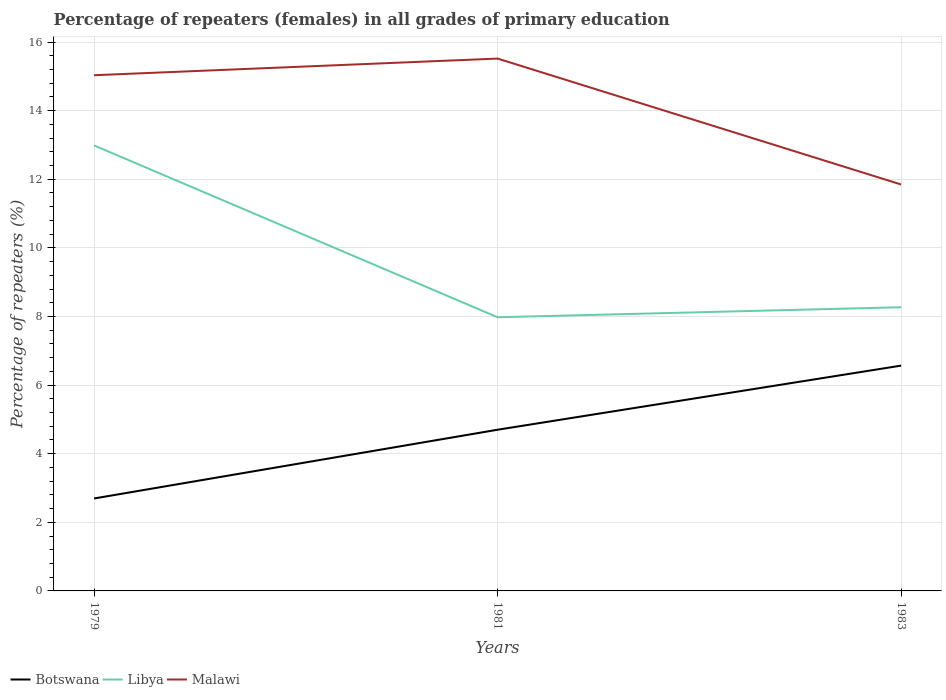How many different coloured lines are there?
Make the answer very short. 3. Does the line corresponding to Botswana intersect with the line corresponding to Malawi?
Your answer should be very brief. No. Is the number of lines equal to the number of legend labels?
Offer a terse response. Yes. Across all years, what is the maximum percentage of repeaters (females) in Botswana?
Offer a very short reply. 2.69. In which year was the percentage of repeaters (females) in Botswana maximum?
Keep it short and to the point. 1979. What is the total percentage of repeaters (females) in Libya in the graph?
Ensure brevity in your answer.  5.01. What is the difference between the highest and the second highest percentage of repeaters (females) in Malawi?
Your answer should be compact. 3.67. Is the percentage of repeaters (females) in Libya strictly greater than the percentage of repeaters (females) in Malawi over the years?
Make the answer very short. Yes. How many lines are there?
Give a very brief answer. 3. Does the graph contain any zero values?
Make the answer very short. No. Does the graph contain grids?
Provide a short and direct response. Yes. How many legend labels are there?
Keep it short and to the point. 3. What is the title of the graph?
Your answer should be very brief. Percentage of repeaters (females) in all grades of primary education. What is the label or title of the Y-axis?
Ensure brevity in your answer.  Percentage of repeaters (%). What is the Percentage of repeaters (%) in Botswana in 1979?
Ensure brevity in your answer.  2.69. What is the Percentage of repeaters (%) of Libya in 1979?
Keep it short and to the point. 12.99. What is the Percentage of repeaters (%) in Malawi in 1979?
Offer a very short reply. 15.03. What is the Percentage of repeaters (%) in Botswana in 1981?
Your response must be concise. 4.7. What is the Percentage of repeaters (%) in Libya in 1981?
Your response must be concise. 7.98. What is the Percentage of repeaters (%) in Malawi in 1981?
Your response must be concise. 15.52. What is the Percentage of repeaters (%) in Botswana in 1983?
Your answer should be compact. 6.57. What is the Percentage of repeaters (%) of Libya in 1983?
Keep it short and to the point. 8.27. What is the Percentage of repeaters (%) in Malawi in 1983?
Ensure brevity in your answer.  11.85. Across all years, what is the maximum Percentage of repeaters (%) in Botswana?
Keep it short and to the point. 6.57. Across all years, what is the maximum Percentage of repeaters (%) of Libya?
Your answer should be very brief. 12.99. Across all years, what is the maximum Percentage of repeaters (%) in Malawi?
Offer a very short reply. 15.52. Across all years, what is the minimum Percentage of repeaters (%) of Botswana?
Your answer should be compact. 2.69. Across all years, what is the minimum Percentage of repeaters (%) of Libya?
Your answer should be compact. 7.98. Across all years, what is the minimum Percentage of repeaters (%) in Malawi?
Your response must be concise. 11.85. What is the total Percentage of repeaters (%) in Botswana in the graph?
Provide a short and direct response. 13.96. What is the total Percentage of repeaters (%) in Libya in the graph?
Keep it short and to the point. 29.23. What is the total Percentage of repeaters (%) of Malawi in the graph?
Offer a very short reply. 42.4. What is the difference between the Percentage of repeaters (%) in Botswana in 1979 and that in 1981?
Offer a terse response. -2. What is the difference between the Percentage of repeaters (%) of Libya in 1979 and that in 1981?
Provide a short and direct response. 5.01. What is the difference between the Percentage of repeaters (%) in Malawi in 1979 and that in 1981?
Provide a short and direct response. -0.49. What is the difference between the Percentage of repeaters (%) in Botswana in 1979 and that in 1983?
Your answer should be compact. -3.87. What is the difference between the Percentage of repeaters (%) in Libya in 1979 and that in 1983?
Offer a very short reply. 4.72. What is the difference between the Percentage of repeaters (%) of Malawi in 1979 and that in 1983?
Give a very brief answer. 3.19. What is the difference between the Percentage of repeaters (%) in Botswana in 1981 and that in 1983?
Keep it short and to the point. -1.87. What is the difference between the Percentage of repeaters (%) in Libya in 1981 and that in 1983?
Your response must be concise. -0.29. What is the difference between the Percentage of repeaters (%) in Malawi in 1981 and that in 1983?
Offer a very short reply. 3.67. What is the difference between the Percentage of repeaters (%) in Botswana in 1979 and the Percentage of repeaters (%) in Libya in 1981?
Your response must be concise. -5.28. What is the difference between the Percentage of repeaters (%) of Botswana in 1979 and the Percentage of repeaters (%) of Malawi in 1981?
Keep it short and to the point. -12.82. What is the difference between the Percentage of repeaters (%) of Libya in 1979 and the Percentage of repeaters (%) of Malawi in 1981?
Your answer should be very brief. -2.53. What is the difference between the Percentage of repeaters (%) in Botswana in 1979 and the Percentage of repeaters (%) in Libya in 1983?
Your answer should be very brief. -5.57. What is the difference between the Percentage of repeaters (%) in Botswana in 1979 and the Percentage of repeaters (%) in Malawi in 1983?
Give a very brief answer. -9.15. What is the difference between the Percentage of repeaters (%) of Libya in 1979 and the Percentage of repeaters (%) of Malawi in 1983?
Your response must be concise. 1.14. What is the difference between the Percentage of repeaters (%) of Botswana in 1981 and the Percentage of repeaters (%) of Libya in 1983?
Your response must be concise. -3.57. What is the difference between the Percentage of repeaters (%) of Botswana in 1981 and the Percentage of repeaters (%) of Malawi in 1983?
Offer a terse response. -7.15. What is the difference between the Percentage of repeaters (%) in Libya in 1981 and the Percentage of repeaters (%) in Malawi in 1983?
Offer a very short reply. -3.87. What is the average Percentage of repeaters (%) of Botswana per year?
Your response must be concise. 4.65. What is the average Percentage of repeaters (%) in Libya per year?
Your answer should be compact. 9.74. What is the average Percentage of repeaters (%) of Malawi per year?
Ensure brevity in your answer.  14.13. In the year 1979, what is the difference between the Percentage of repeaters (%) of Botswana and Percentage of repeaters (%) of Libya?
Your answer should be compact. -10.29. In the year 1979, what is the difference between the Percentage of repeaters (%) in Botswana and Percentage of repeaters (%) in Malawi?
Keep it short and to the point. -12.34. In the year 1979, what is the difference between the Percentage of repeaters (%) in Libya and Percentage of repeaters (%) in Malawi?
Ensure brevity in your answer.  -2.05. In the year 1981, what is the difference between the Percentage of repeaters (%) of Botswana and Percentage of repeaters (%) of Libya?
Your answer should be compact. -3.28. In the year 1981, what is the difference between the Percentage of repeaters (%) of Botswana and Percentage of repeaters (%) of Malawi?
Ensure brevity in your answer.  -10.82. In the year 1981, what is the difference between the Percentage of repeaters (%) in Libya and Percentage of repeaters (%) in Malawi?
Your answer should be compact. -7.54. In the year 1983, what is the difference between the Percentage of repeaters (%) of Botswana and Percentage of repeaters (%) of Libya?
Make the answer very short. -1.7. In the year 1983, what is the difference between the Percentage of repeaters (%) in Botswana and Percentage of repeaters (%) in Malawi?
Provide a short and direct response. -5.28. In the year 1983, what is the difference between the Percentage of repeaters (%) of Libya and Percentage of repeaters (%) of Malawi?
Provide a short and direct response. -3.58. What is the ratio of the Percentage of repeaters (%) in Botswana in 1979 to that in 1981?
Offer a very short reply. 0.57. What is the ratio of the Percentage of repeaters (%) in Libya in 1979 to that in 1981?
Ensure brevity in your answer.  1.63. What is the ratio of the Percentage of repeaters (%) in Malawi in 1979 to that in 1981?
Ensure brevity in your answer.  0.97. What is the ratio of the Percentage of repeaters (%) in Botswana in 1979 to that in 1983?
Provide a succinct answer. 0.41. What is the ratio of the Percentage of repeaters (%) of Libya in 1979 to that in 1983?
Make the answer very short. 1.57. What is the ratio of the Percentage of repeaters (%) of Malawi in 1979 to that in 1983?
Give a very brief answer. 1.27. What is the ratio of the Percentage of repeaters (%) of Botswana in 1981 to that in 1983?
Keep it short and to the point. 0.72. What is the ratio of the Percentage of repeaters (%) in Libya in 1981 to that in 1983?
Make the answer very short. 0.96. What is the ratio of the Percentage of repeaters (%) in Malawi in 1981 to that in 1983?
Provide a succinct answer. 1.31. What is the difference between the highest and the second highest Percentage of repeaters (%) in Botswana?
Offer a very short reply. 1.87. What is the difference between the highest and the second highest Percentage of repeaters (%) of Libya?
Provide a succinct answer. 4.72. What is the difference between the highest and the second highest Percentage of repeaters (%) of Malawi?
Provide a succinct answer. 0.49. What is the difference between the highest and the lowest Percentage of repeaters (%) of Botswana?
Your answer should be compact. 3.87. What is the difference between the highest and the lowest Percentage of repeaters (%) in Libya?
Your response must be concise. 5.01. What is the difference between the highest and the lowest Percentage of repeaters (%) of Malawi?
Offer a very short reply. 3.67. 